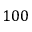<formula> <loc_0><loc_0><loc_500><loc_500>1 0 0</formula> 